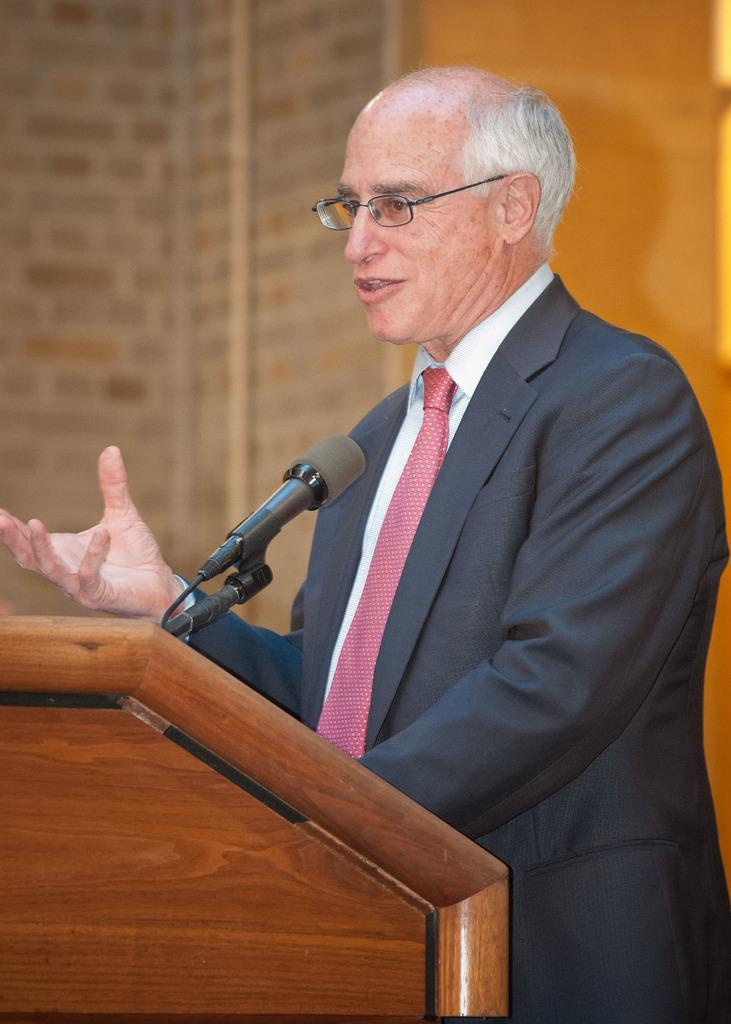What is the man in the image doing? The man is talking on a microphone. What is the man wearing in the image? The man is wearing a black suit. What accessory does the man have in the image? The man has spectacles. What object is present in the image that the man might be using? There is a podium in the image. What can be seen in the background of the image? There is a wall in the background of the image. What type of spoon is the man using to express his beliefs in the image? There is no spoon present in the image, and the man is not expressing any beliefs. 